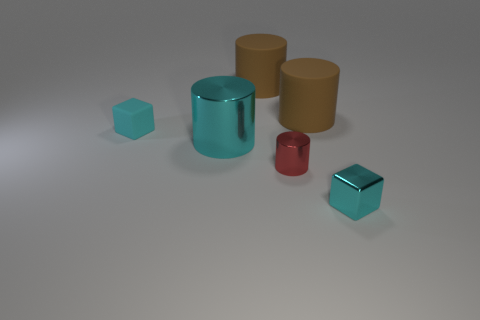There is a large shiny cylinder; does it have the same color as the small metal object in front of the small cylinder?
Keep it short and to the point. Yes. Are there an equal number of small cyan objects that are on the left side of the small cyan metal cube and tiny red cylinders that are right of the tiny cyan matte cube?
Your answer should be compact. Yes. How many big rubber things are the same shape as the tiny red metal object?
Offer a very short reply. 2. Are there any red metal things?
Offer a terse response. Yes. Do the big cyan thing and the small block that is behind the small red thing have the same material?
Offer a terse response. No. There is another cyan block that is the same size as the cyan rubber cube; what material is it?
Your response must be concise. Metal. Is there a large cyan object made of the same material as the small red cylinder?
Offer a very short reply. Yes. There is a cyan block that is to the right of the metallic object that is behind the small red cylinder; are there any cyan shiny things that are on the left side of it?
Your answer should be compact. Yes. There is a cyan metallic object that is the same size as the red metallic object; what is its shape?
Provide a succinct answer. Cube. Does the cube in front of the cyan matte block have the same size as the block behind the small red metal cylinder?
Keep it short and to the point. Yes. 